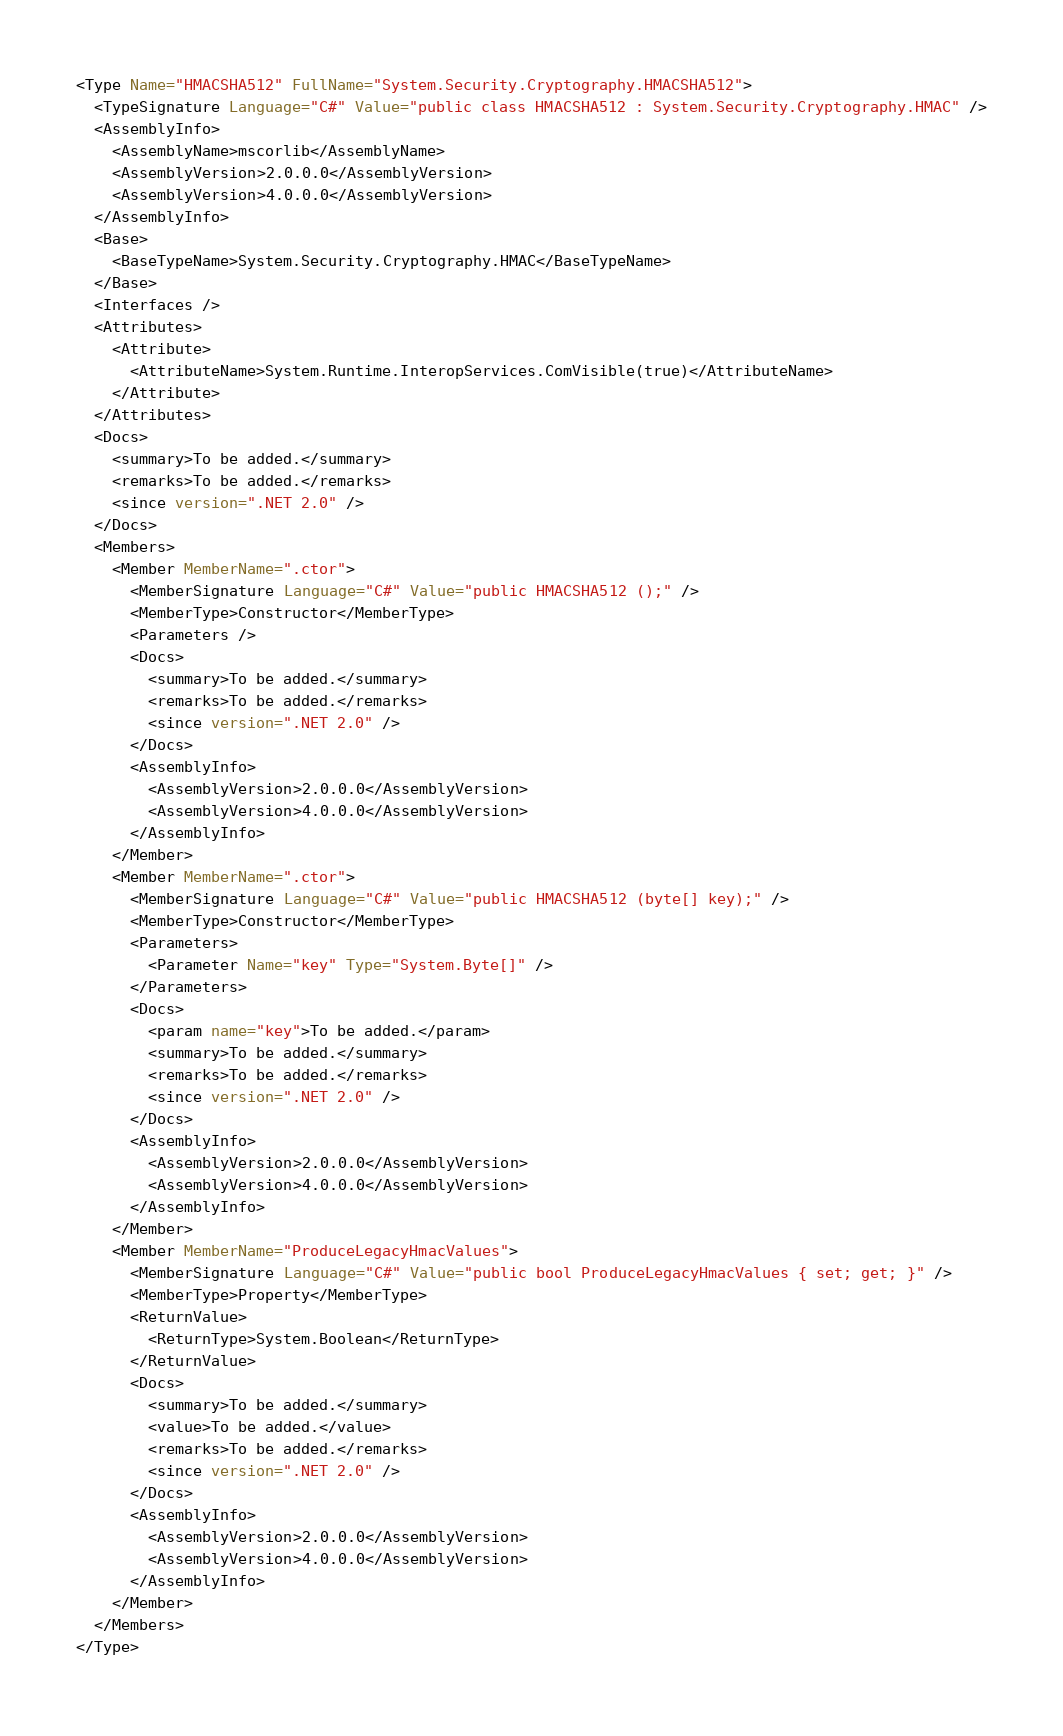Convert code to text. <code><loc_0><loc_0><loc_500><loc_500><_XML_><Type Name="HMACSHA512" FullName="System.Security.Cryptography.HMACSHA512">
  <TypeSignature Language="C#" Value="public class HMACSHA512 : System.Security.Cryptography.HMAC" />
  <AssemblyInfo>
    <AssemblyName>mscorlib</AssemblyName>
    <AssemblyVersion>2.0.0.0</AssemblyVersion>
    <AssemblyVersion>4.0.0.0</AssemblyVersion>
  </AssemblyInfo>
  <Base>
    <BaseTypeName>System.Security.Cryptography.HMAC</BaseTypeName>
  </Base>
  <Interfaces />
  <Attributes>
    <Attribute>
      <AttributeName>System.Runtime.InteropServices.ComVisible(true)</AttributeName>
    </Attribute>
  </Attributes>
  <Docs>
    <summary>To be added.</summary>
    <remarks>To be added.</remarks>
    <since version=".NET 2.0" />
  </Docs>
  <Members>
    <Member MemberName=".ctor">
      <MemberSignature Language="C#" Value="public HMACSHA512 ();" />
      <MemberType>Constructor</MemberType>
      <Parameters />
      <Docs>
        <summary>To be added.</summary>
        <remarks>To be added.</remarks>
        <since version=".NET 2.0" />
      </Docs>
      <AssemblyInfo>
        <AssemblyVersion>2.0.0.0</AssemblyVersion>
        <AssemblyVersion>4.0.0.0</AssemblyVersion>
      </AssemblyInfo>
    </Member>
    <Member MemberName=".ctor">
      <MemberSignature Language="C#" Value="public HMACSHA512 (byte[] key);" />
      <MemberType>Constructor</MemberType>
      <Parameters>
        <Parameter Name="key" Type="System.Byte[]" />
      </Parameters>
      <Docs>
        <param name="key">To be added.</param>
        <summary>To be added.</summary>
        <remarks>To be added.</remarks>
        <since version=".NET 2.0" />
      </Docs>
      <AssemblyInfo>
        <AssemblyVersion>2.0.0.0</AssemblyVersion>
        <AssemblyVersion>4.0.0.0</AssemblyVersion>
      </AssemblyInfo>
    </Member>
    <Member MemberName="ProduceLegacyHmacValues">
      <MemberSignature Language="C#" Value="public bool ProduceLegacyHmacValues { set; get; }" />
      <MemberType>Property</MemberType>
      <ReturnValue>
        <ReturnType>System.Boolean</ReturnType>
      </ReturnValue>
      <Docs>
        <summary>To be added.</summary>
        <value>To be added.</value>
        <remarks>To be added.</remarks>
        <since version=".NET 2.0" />
      </Docs>
      <AssemblyInfo>
        <AssemblyVersion>2.0.0.0</AssemblyVersion>
        <AssemblyVersion>4.0.0.0</AssemblyVersion>
      </AssemblyInfo>
    </Member>
  </Members>
</Type>
</code> 